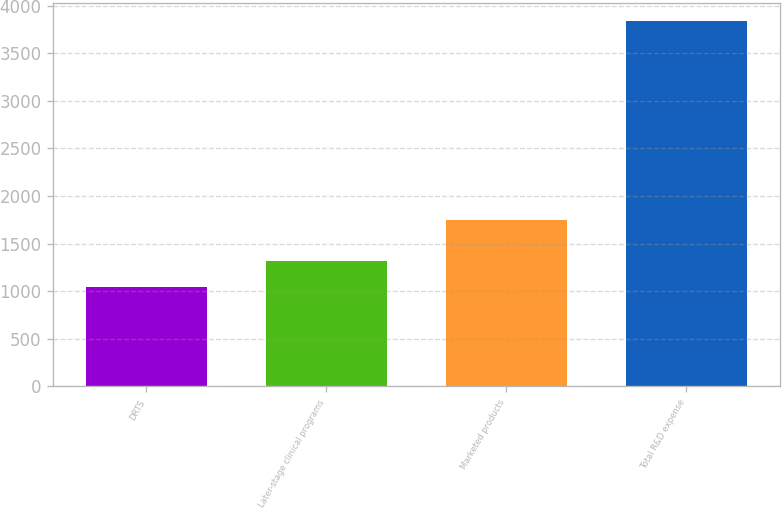Convert chart to OTSL. <chart><loc_0><loc_0><loc_500><loc_500><bar_chart><fcel>DRTS<fcel>Later-stage clinical programs<fcel>Marketed products<fcel>Total R&D expense<nl><fcel>1039<fcel>1319.1<fcel>1747<fcel>3840<nl></chart> 